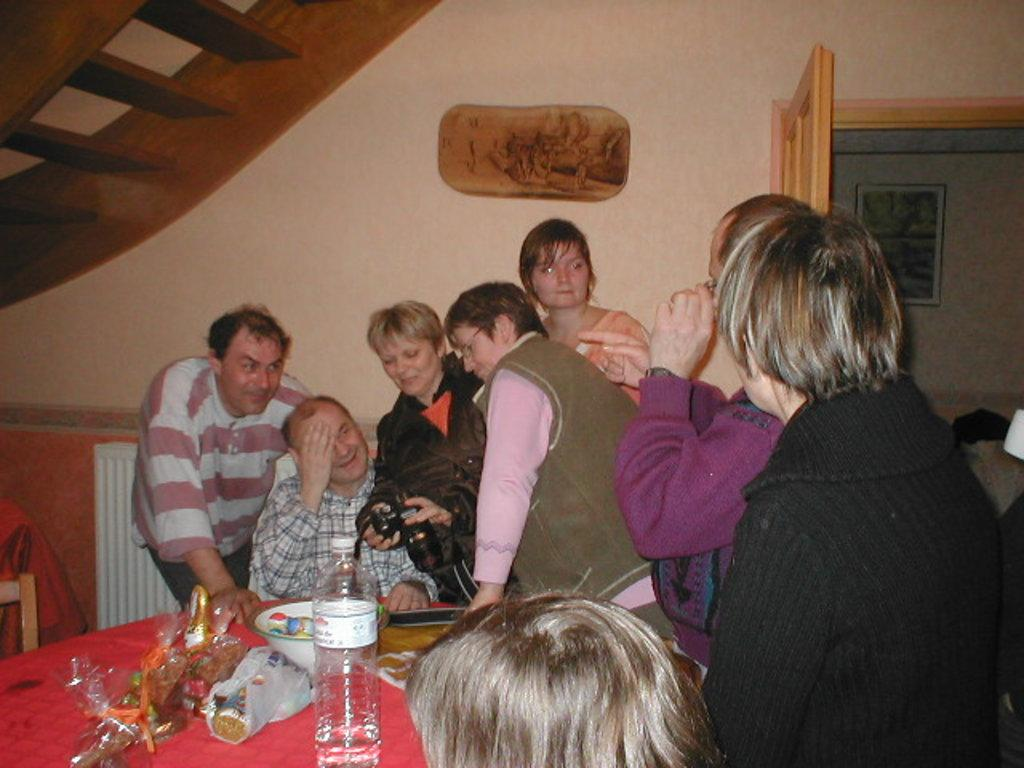What is happening around the table in the image? There are people around a table in the image. What is the woman holding in the image? The woman is holding a camera in the image. What can be seen on the table in the image? There is a bowl visible in the image. What is another object visible in the image? There is a water bottle in the image. What type of grain is being harvested in the image? There is no grain or harvesting activity present in the image. How many people are resting around the table in the image? The image does not depict people resting; they are around the table, but their actions are not specified. 